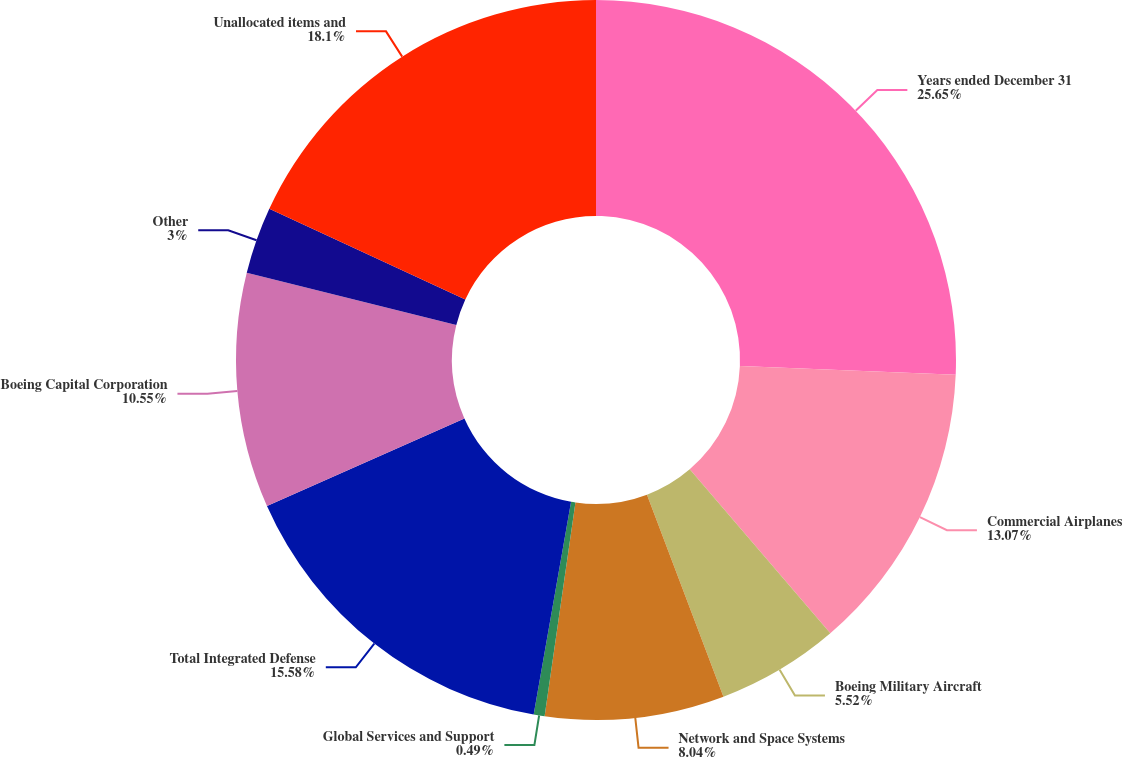Convert chart to OTSL. <chart><loc_0><loc_0><loc_500><loc_500><pie_chart><fcel>Years ended December 31<fcel>Commercial Airplanes<fcel>Boeing Military Aircraft<fcel>Network and Space Systems<fcel>Global Services and Support<fcel>Total Integrated Defense<fcel>Boeing Capital Corporation<fcel>Other<fcel>Unallocated items and<nl><fcel>25.65%<fcel>13.07%<fcel>5.52%<fcel>8.04%<fcel>0.49%<fcel>15.58%<fcel>10.55%<fcel>3.0%<fcel>18.1%<nl></chart> 